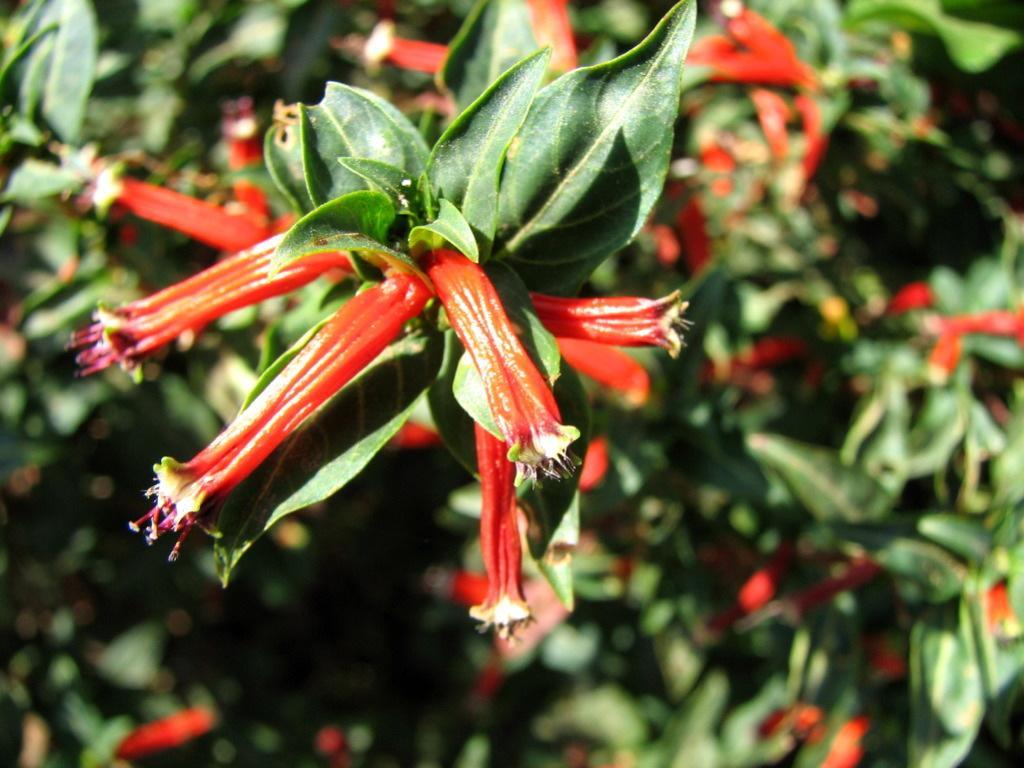In one or two sentences, can you explain what this image depicts? In the image in the center, we can see plants and flowers, which are in red color. 